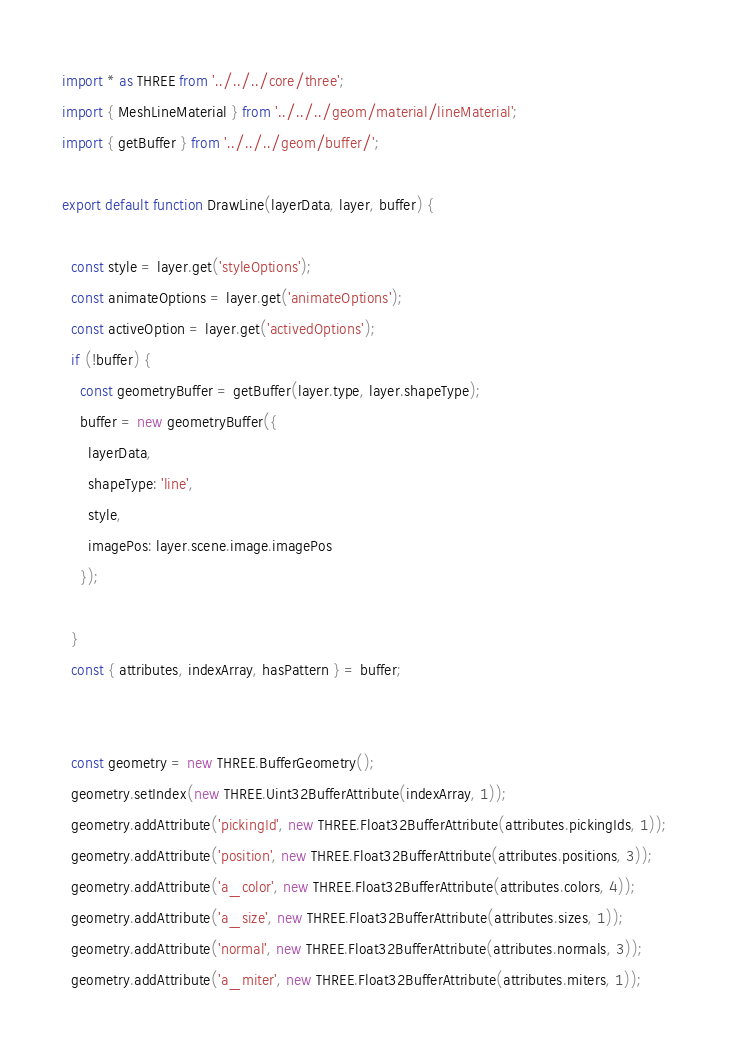<code> <loc_0><loc_0><loc_500><loc_500><_JavaScript_>import * as THREE from '../../../core/three';
import { MeshLineMaterial } from '../../../geom/material/lineMaterial';
import { getBuffer } from '../../../geom/buffer/';

export default function DrawLine(layerData, layer, buffer) {

  const style = layer.get('styleOptions');
  const animateOptions = layer.get('animateOptions');
  const activeOption = layer.get('activedOptions');
  if (!buffer) {
    const geometryBuffer = getBuffer(layer.type, layer.shapeType);
    buffer = new geometryBuffer({
      layerData,
      shapeType: 'line',
      style,
      imagePos: layer.scene.image.imagePos
    });

  }
  const { attributes, indexArray, hasPattern } = buffer;


  const geometry = new THREE.BufferGeometry();
  geometry.setIndex(new THREE.Uint32BufferAttribute(indexArray, 1));
  geometry.addAttribute('pickingId', new THREE.Float32BufferAttribute(attributes.pickingIds, 1));
  geometry.addAttribute('position', new THREE.Float32BufferAttribute(attributes.positions, 3));
  geometry.addAttribute('a_color', new THREE.Float32BufferAttribute(attributes.colors, 4));
  geometry.addAttribute('a_size', new THREE.Float32BufferAttribute(attributes.sizes, 1));
  geometry.addAttribute('normal', new THREE.Float32BufferAttribute(attributes.normals, 3));
  geometry.addAttribute('a_miter', new THREE.Float32BufferAttribute(attributes.miters, 1));</code> 